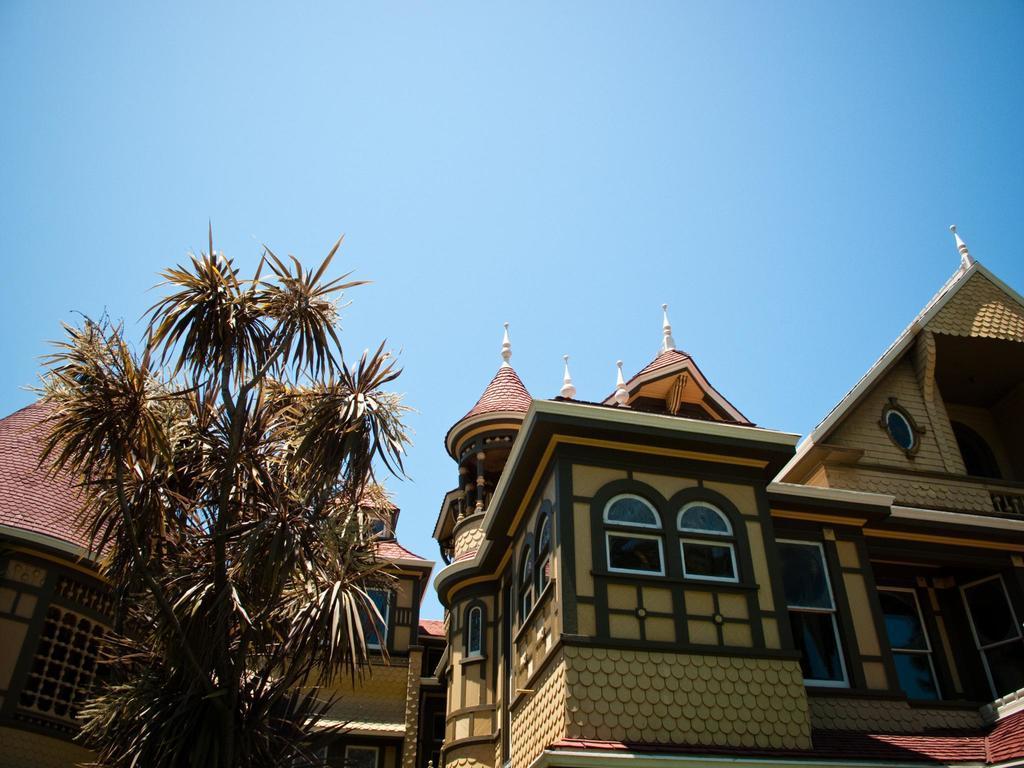In one or two sentences, can you explain what this image depicts? In this picture I can see buildings and a tree and I can see blue sky. 